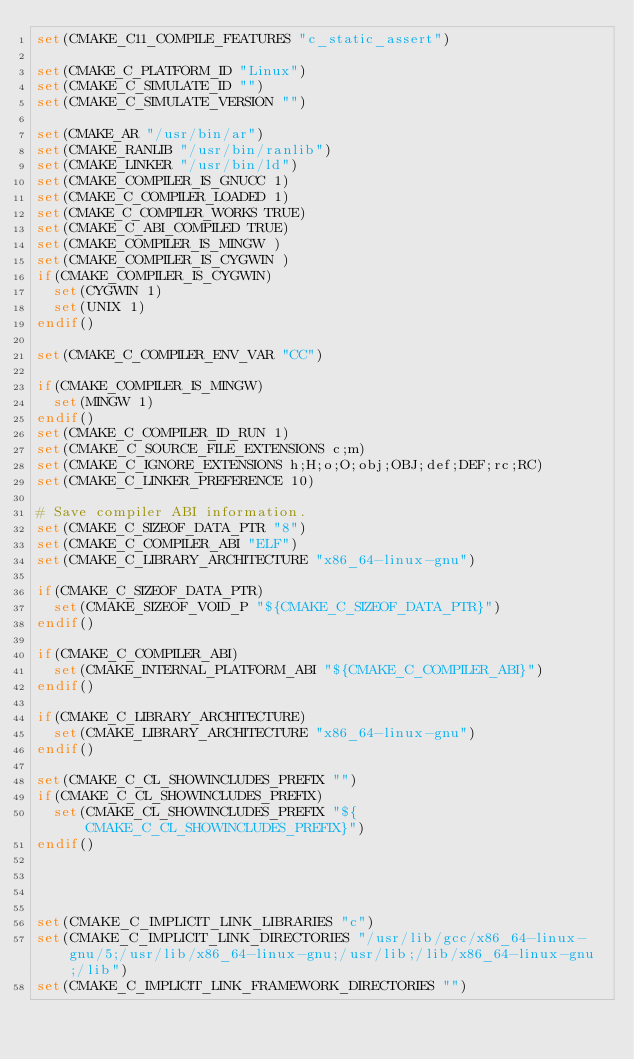Convert code to text. <code><loc_0><loc_0><loc_500><loc_500><_CMake_>set(CMAKE_C11_COMPILE_FEATURES "c_static_assert")

set(CMAKE_C_PLATFORM_ID "Linux")
set(CMAKE_C_SIMULATE_ID "")
set(CMAKE_C_SIMULATE_VERSION "")

set(CMAKE_AR "/usr/bin/ar")
set(CMAKE_RANLIB "/usr/bin/ranlib")
set(CMAKE_LINKER "/usr/bin/ld")
set(CMAKE_COMPILER_IS_GNUCC 1)
set(CMAKE_C_COMPILER_LOADED 1)
set(CMAKE_C_COMPILER_WORKS TRUE)
set(CMAKE_C_ABI_COMPILED TRUE)
set(CMAKE_COMPILER_IS_MINGW )
set(CMAKE_COMPILER_IS_CYGWIN )
if(CMAKE_COMPILER_IS_CYGWIN)
  set(CYGWIN 1)
  set(UNIX 1)
endif()

set(CMAKE_C_COMPILER_ENV_VAR "CC")

if(CMAKE_COMPILER_IS_MINGW)
  set(MINGW 1)
endif()
set(CMAKE_C_COMPILER_ID_RUN 1)
set(CMAKE_C_SOURCE_FILE_EXTENSIONS c;m)
set(CMAKE_C_IGNORE_EXTENSIONS h;H;o;O;obj;OBJ;def;DEF;rc;RC)
set(CMAKE_C_LINKER_PREFERENCE 10)

# Save compiler ABI information.
set(CMAKE_C_SIZEOF_DATA_PTR "8")
set(CMAKE_C_COMPILER_ABI "ELF")
set(CMAKE_C_LIBRARY_ARCHITECTURE "x86_64-linux-gnu")

if(CMAKE_C_SIZEOF_DATA_PTR)
  set(CMAKE_SIZEOF_VOID_P "${CMAKE_C_SIZEOF_DATA_PTR}")
endif()

if(CMAKE_C_COMPILER_ABI)
  set(CMAKE_INTERNAL_PLATFORM_ABI "${CMAKE_C_COMPILER_ABI}")
endif()

if(CMAKE_C_LIBRARY_ARCHITECTURE)
  set(CMAKE_LIBRARY_ARCHITECTURE "x86_64-linux-gnu")
endif()

set(CMAKE_C_CL_SHOWINCLUDES_PREFIX "")
if(CMAKE_C_CL_SHOWINCLUDES_PREFIX)
  set(CMAKE_CL_SHOWINCLUDES_PREFIX "${CMAKE_C_CL_SHOWINCLUDES_PREFIX}")
endif()




set(CMAKE_C_IMPLICIT_LINK_LIBRARIES "c")
set(CMAKE_C_IMPLICIT_LINK_DIRECTORIES "/usr/lib/gcc/x86_64-linux-gnu/5;/usr/lib/x86_64-linux-gnu;/usr/lib;/lib/x86_64-linux-gnu;/lib")
set(CMAKE_C_IMPLICIT_LINK_FRAMEWORK_DIRECTORIES "")
</code> 